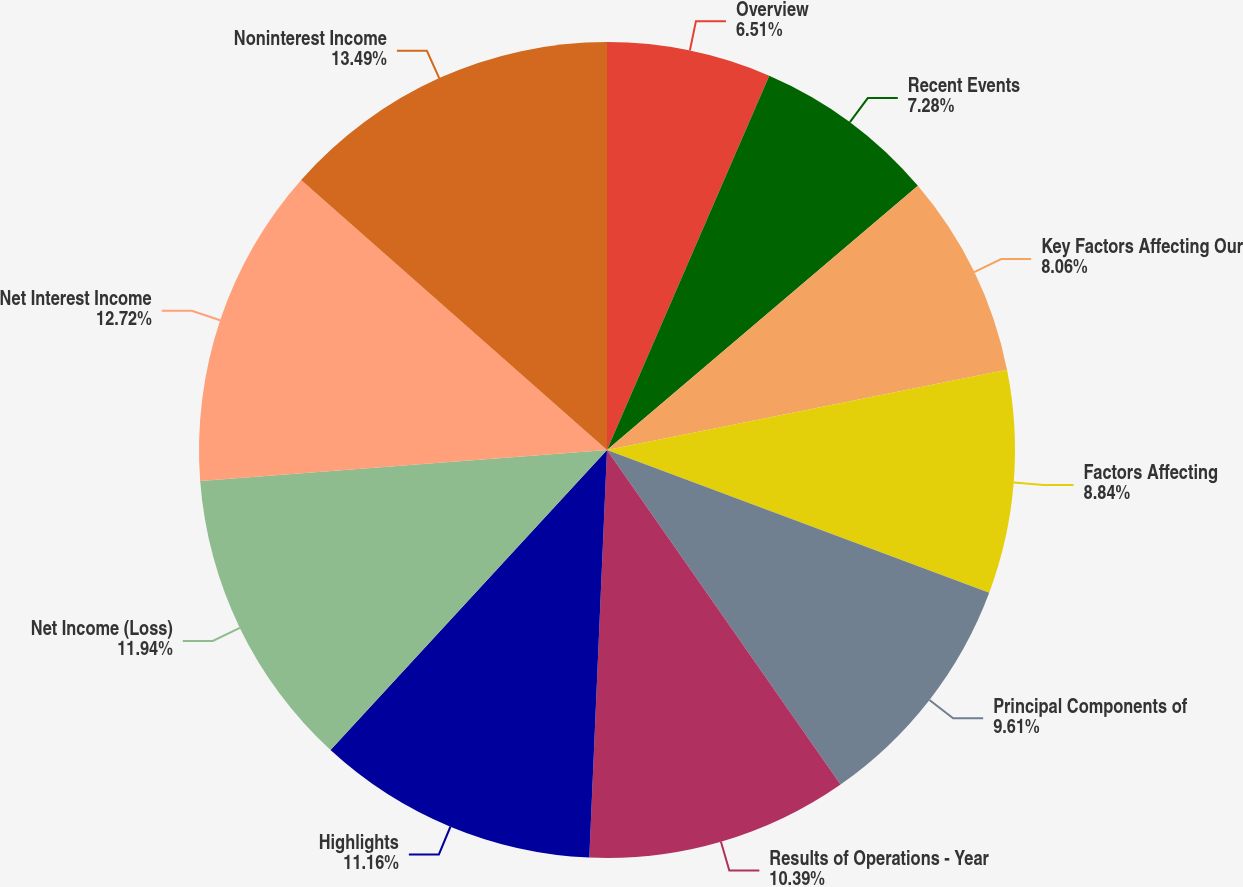Convert chart. <chart><loc_0><loc_0><loc_500><loc_500><pie_chart><fcel>Overview<fcel>Recent Events<fcel>Key Factors Affecting Our<fcel>Factors Affecting<fcel>Principal Components of<fcel>Results of Operations - Year<fcel>Highlights<fcel>Net Income (Loss)<fcel>Net Interest Income<fcel>Noninterest Income<nl><fcel>6.51%<fcel>7.28%<fcel>8.06%<fcel>8.84%<fcel>9.61%<fcel>10.39%<fcel>11.16%<fcel>11.94%<fcel>12.72%<fcel>13.49%<nl></chart> 